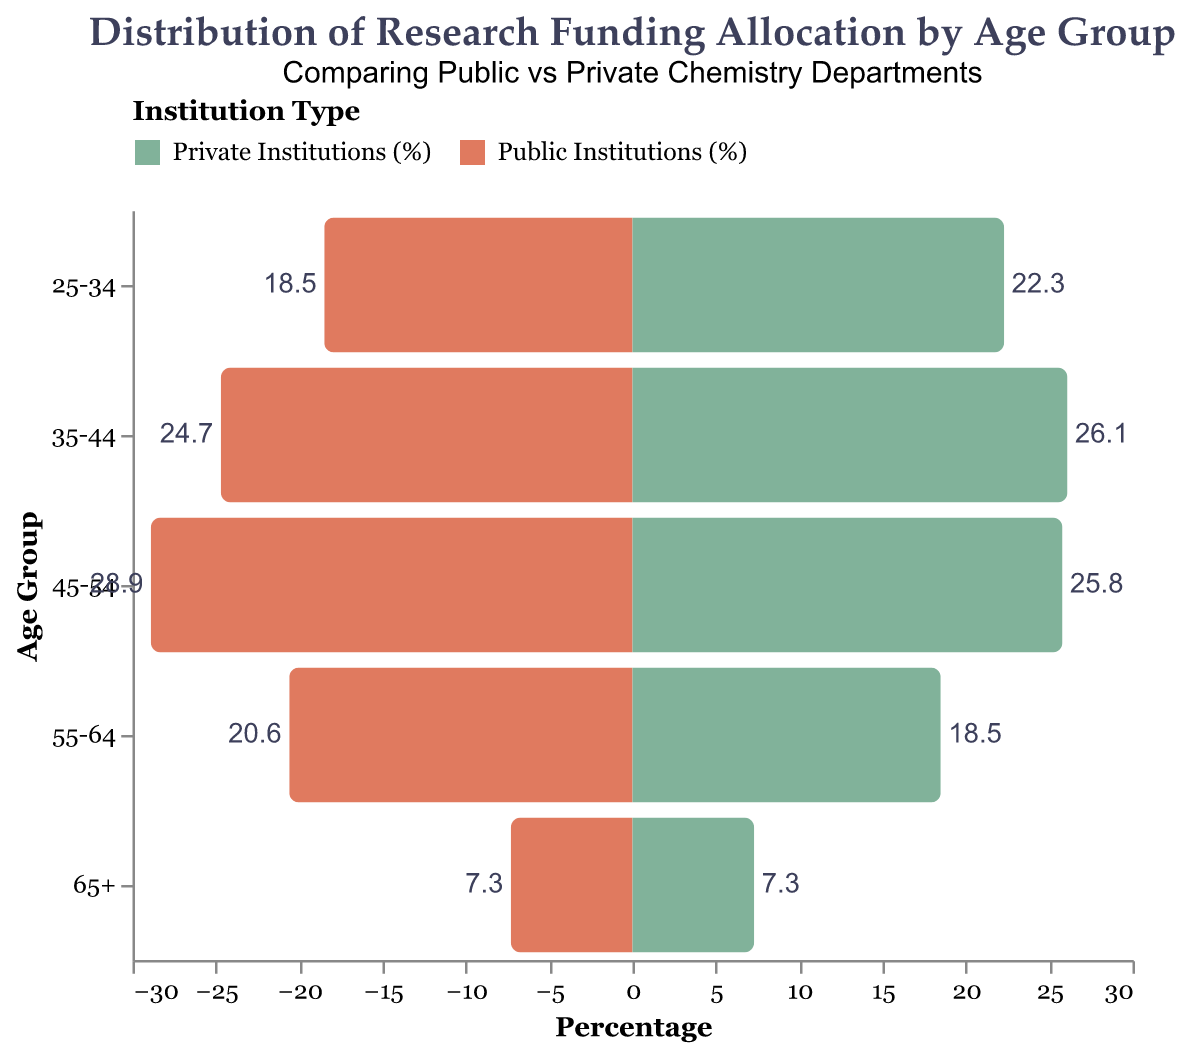What is the highest percentage allocation for private institutions by age group? Look at the "Private Institutions (%)" column and identify the age group with the largest percentage. The "35-44" age group has the highest percentage of 26.1%.
Answer: 26.1% Which institution type allocates more research funding to the "55-64" age group? Compare the percentages for public and private institutions in the "55-64" age group. Public institutions allocate 20.6% while private institutions allocate 18.5%.
Answer: Public institutions What is the total research funding percentage allocated by private institutions for all age groups? Sum the percentages for all age groups under "Private Institutions (%)" (22.3 + 26.1 + 25.8 + 18.5 + 7.3). Thus, the total is 100.0%.
Answer: 100.0% How much more percentage funding does the "35-44" age group receive in private institutions compared to the "25-34" age group in public institutions? Calculate the difference between the percentage allocations: 26.1% (private, 35-44) - 18.5% (public, 25-34) = 7.6%.
Answer: 7.6% Which age group receives an equal percentage of funding from both public and private institutions? Identify the age group where the percentages are the same for both institutions. The "65+" age group has an equal percentage of 7.3% in both cases.
Answer: 65+ What is the average percentage funding allocation for public institutions across all age groups? Sum the percentages for all age groups under "Public Institutions (%)" (18.5 + 24.7 + 28.9 + 20.6 + 7.3) and divide by the number of age groups (5): (18.5 + 24.7 + 28.9 + 20.6 + 7.3) / 5 = 20.0%.
Answer: 20.0% 